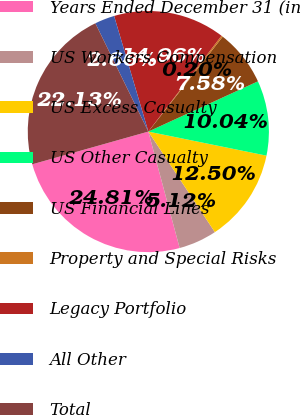<chart> <loc_0><loc_0><loc_500><loc_500><pie_chart><fcel>Years Ended December 31 (in<fcel>US Workers Compensation<fcel>US Excess Casualty<fcel>US Other Casualty<fcel>US Financial Lines<fcel>Property and Special Risks<fcel>Legacy Portfolio<fcel>All Other<fcel>Total<nl><fcel>24.81%<fcel>5.12%<fcel>12.5%<fcel>10.04%<fcel>7.58%<fcel>0.2%<fcel>14.96%<fcel>2.66%<fcel>22.13%<nl></chart> 